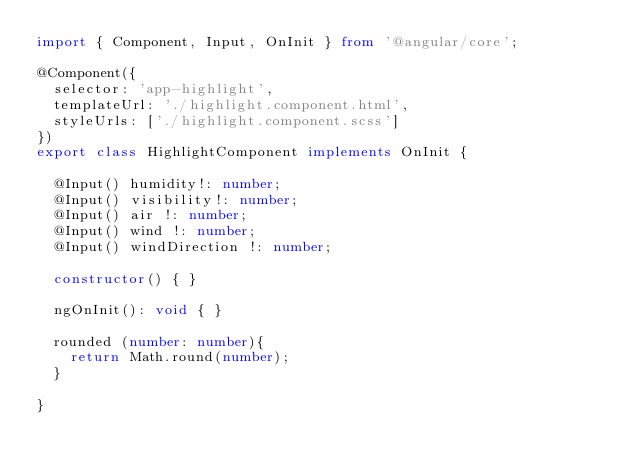Convert code to text. <code><loc_0><loc_0><loc_500><loc_500><_TypeScript_>import { Component, Input, OnInit } from '@angular/core';

@Component({
  selector: 'app-highlight',
  templateUrl: './highlight.component.html',
  styleUrls: ['./highlight.component.scss']
})
export class HighlightComponent implements OnInit {

  @Input() humidity!: number;
  @Input() visibility!: number;
  @Input() air !: number;
  @Input() wind !: number;
  @Input() windDirection !: number;

  constructor() { }

  ngOnInit(): void { }

  rounded (number: number){
    return Math.round(number);
  }

}
</code> 